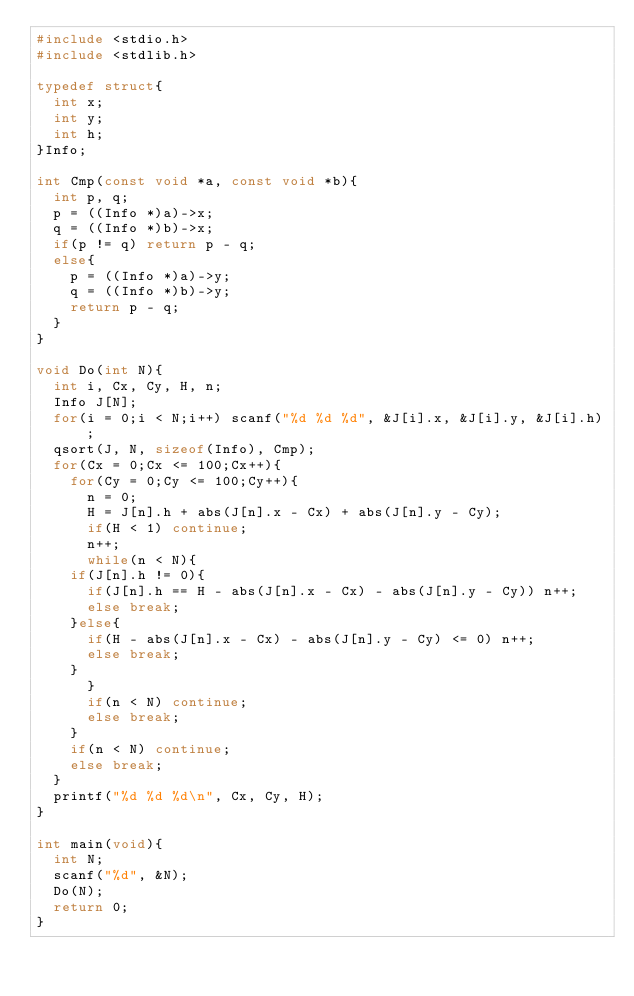<code> <loc_0><loc_0><loc_500><loc_500><_C_>#include <stdio.h>
#include <stdlib.h>

typedef struct{
  int x;
  int y;
  int h;
}Info;

int Cmp(const void *a, const void *b){
  int p, q;
  p = ((Info *)a)->x;
  q = ((Info *)b)->x;
  if(p != q) return p - q;
  else{
    p = ((Info *)a)->y;
    q = ((Info *)b)->y;
    return p - q;
  }
}

void Do(int N){
  int i, Cx, Cy, H, n;
  Info J[N];
  for(i = 0;i < N;i++) scanf("%d %d %d", &J[i].x, &J[i].y, &J[i].h);
  qsort(J, N, sizeof(Info), Cmp);
  for(Cx = 0;Cx <= 100;Cx++){
    for(Cy = 0;Cy <= 100;Cy++){
      n = 0;
      H = J[n].h + abs(J[n].x - Cx) + abs(J[n].y - Cy);
      if(H < 1) continue;
      n++;
      while(n < N){
	if(J[n].h != 0){
	  if(J[n].h == H - abs(J[n].x - Cx) - abs(J[n].y - Cy)) n++;
	  else break;
	}else{
	  if(H - abs(J[n].x - Cx) - abs(J[n].y - Cy) <= 0) n++;
	  else break;
	}
      }
      if(n < N) continue;
      else break;
    }
    if(n < N) continue;
    else break;
  }
  printf("%d %d %d\n", Cx, Cy, H);
}

int main(void){
  int N;
  scanf("%d", &N);
  Do(N);
  return 0;
}
</code> 